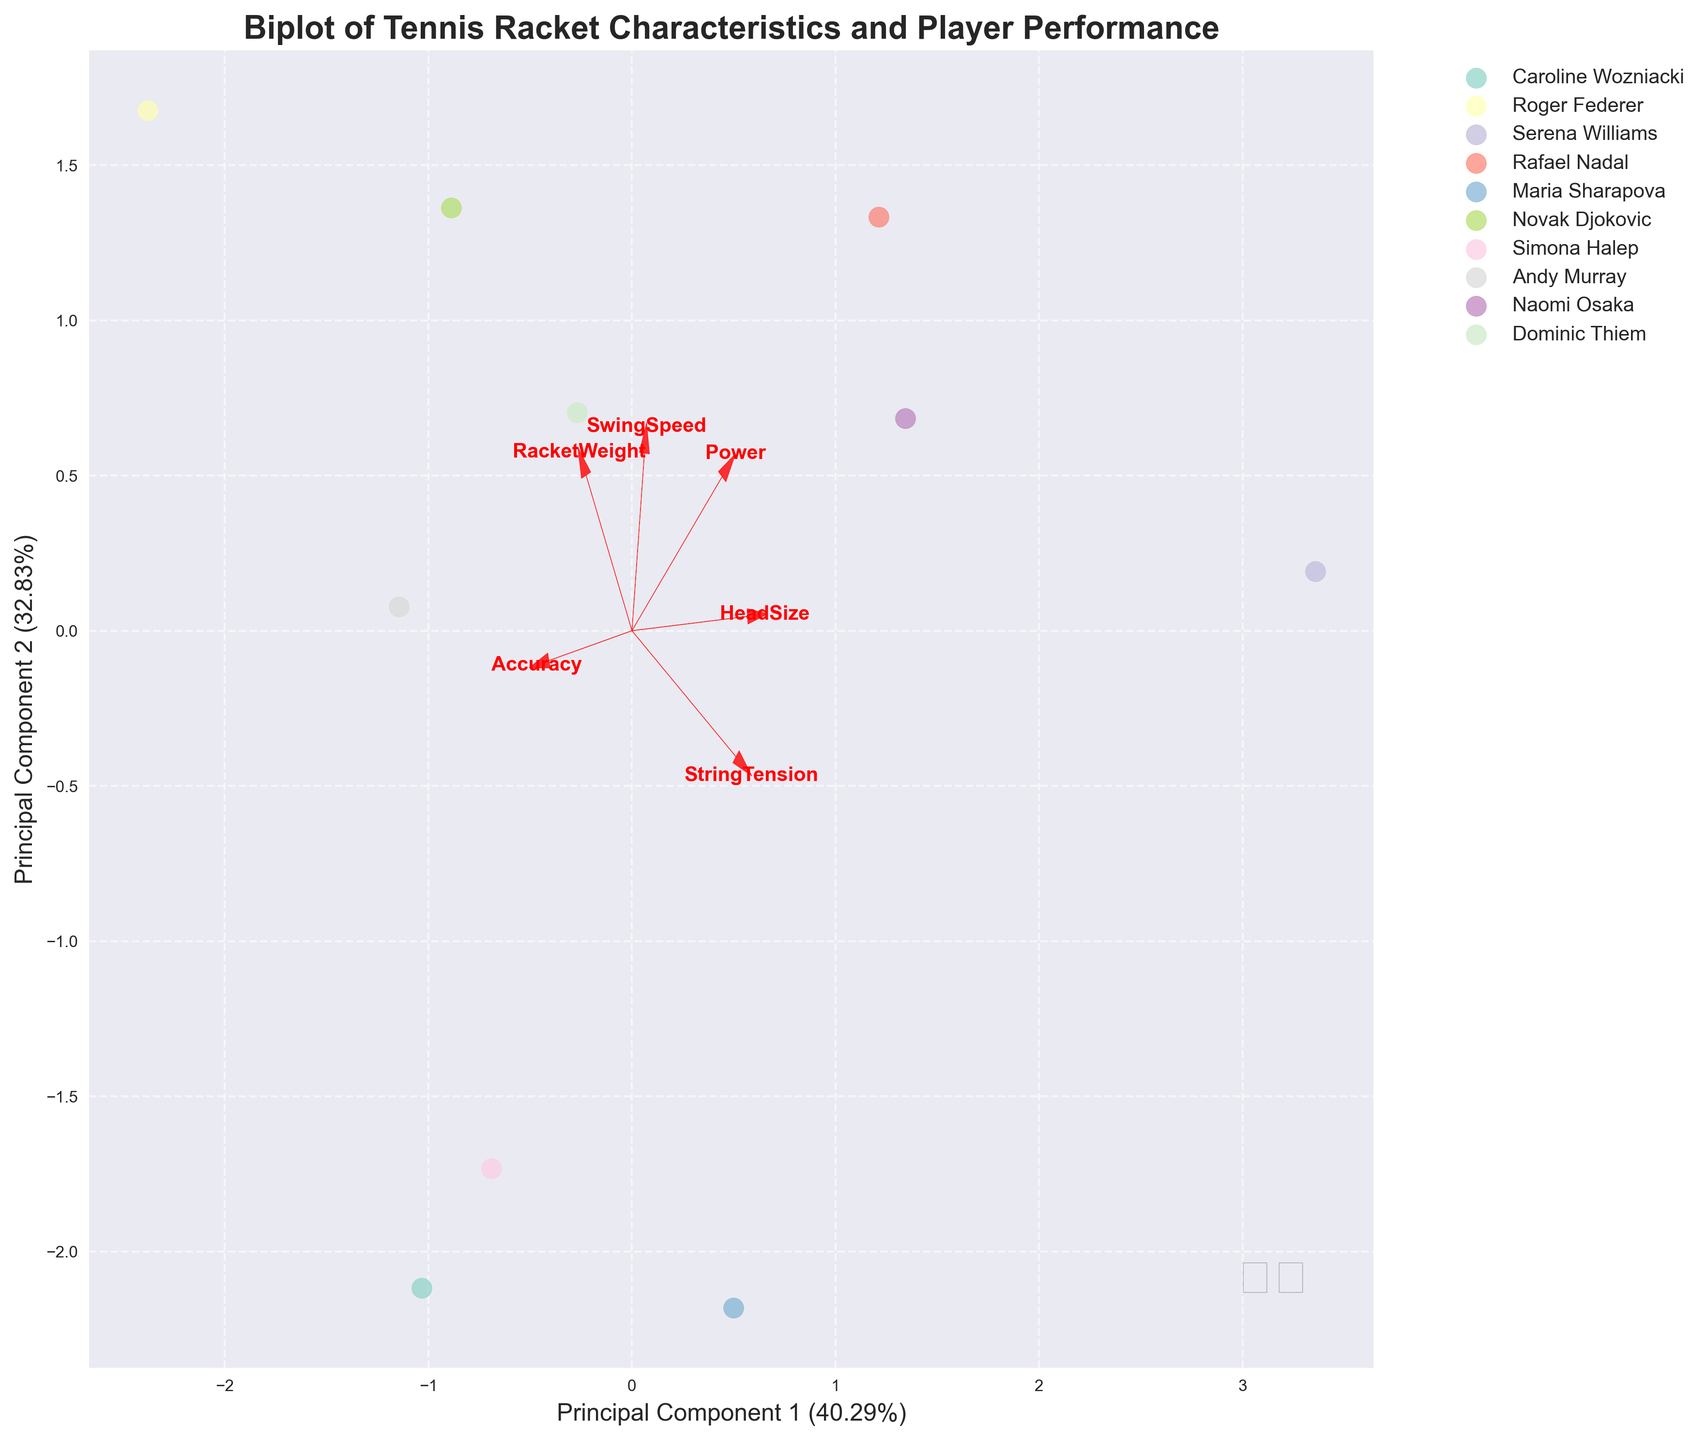What is the title of the figure? The title is located at the top of the figure. It summarizes what the figure is about. In this case, it explains that the figure is a biplot comparing tennis racket characteristics and player performance.
Answer: Biplot of Tennis Racket Characteristics and Player Performance Which player is represented with the most dominant color in the figure? Each player is assigned a unique color for representation in the figure. By observing the scatter plot, we can identify the player associated with the most dominant color.
Answer: Roger Federer Which feature vector is pointing most strongly towards the right of the plot? The feature vectors are represented by arrows. By comparing the directions and lengths of these arrows, we can determine which feature vector points most strongly towards the right.
Answer: Power Which players have similar racket characteristics according to the plot? Players with similar racket characteristics will be located close to each other in the PCA plot. By finding clusters or players close together, we can identify these players.
Answer: Caroline Wozniacki and Simona Halep Which principal component explains the highest variance in the data? The axis labels provide the percentage of variance explained by each principal component. By comparing these values, we can identify the principal component that explains the highest variance.
Answer: Principal Component 1 How do 'Accuracy' and 'SwingSpeed' vectors compare in their directions? The directions of feature vectors can be compared to understand their relative angles. Observing the arrows for 'Accuracy' and 'SwingSpeed' will show their comparative directions.
Answer: They are pointing in similar directions Which player has characteristics that contribute most to principal component 2? By locating the player whose position on the PCA plot aligns most strongly with the axis of principal component 2, we can determine this player.
Answer: Serena Williams What do the lengths of the feature vectors indicate about the importance of the features? The lengths of the vectors represent the strength and significance of each feature in the principal component space. Longer vectors indicate more important features.
Answer: Longer vectors indicate more important features Are there any players whose racket features are almost entirely described by just one of the principal components? Provide an example. Players whose position on the PCA plot aligns closely with just one principal component axis are described more by that component. By identifying one such player, an example can be given.
Answer: Serena Williams is largely aligned with Principal Component 2 